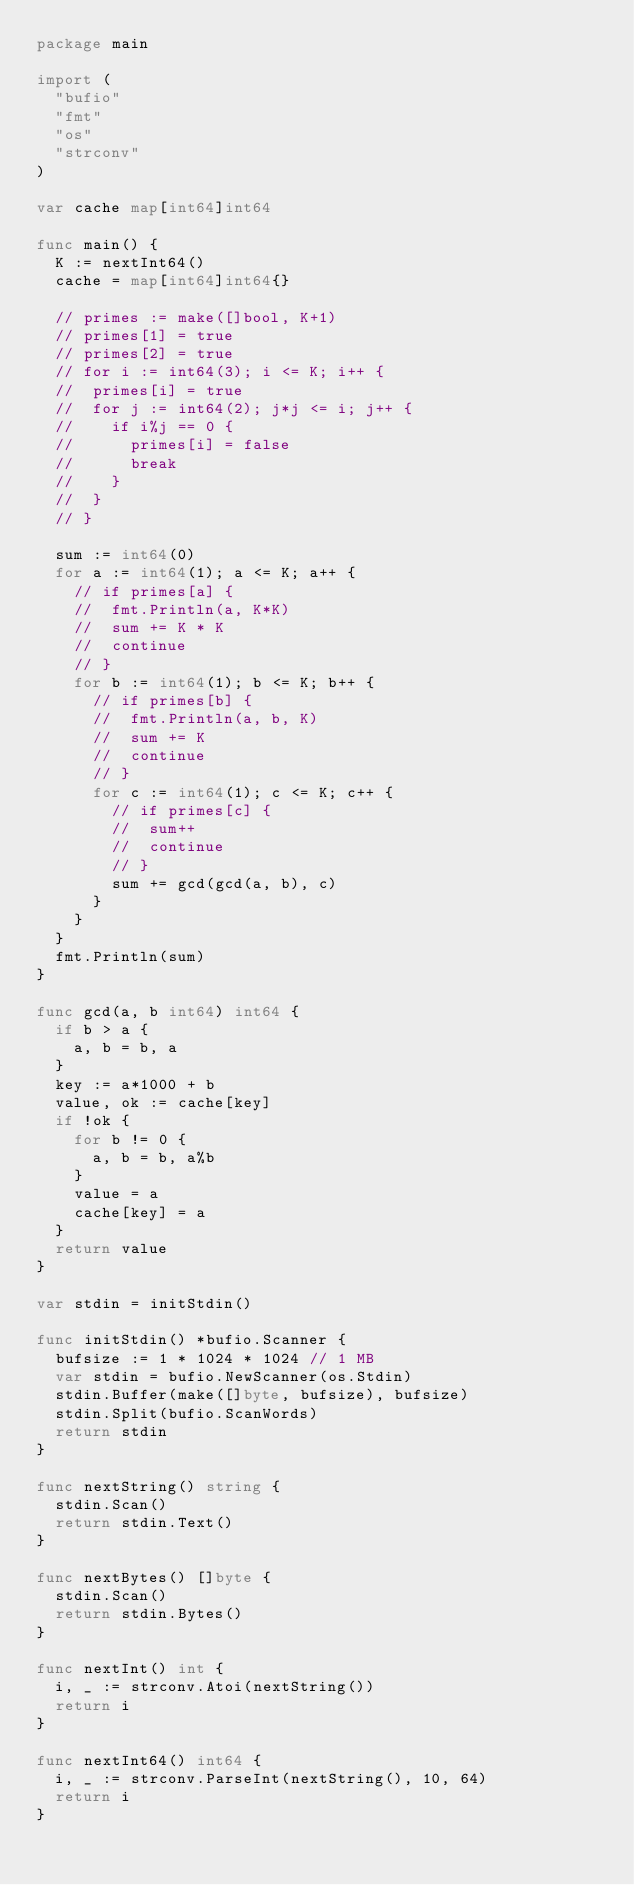Convert code to text. <code><loc_0><loc_0><loc_500><loc_500><_Go_>package main

import (
	"bufio"
	"fmt"
	"os"
	"strconv"
)

var cache map[int64]int64

func main() {
	K := nextInt64()
	cache = map[int64]int64{}

	// primes := make([]bool, K+1)
	// primes[1] = true
	// primes[2] = true
	// for i := int64(3); i <= K; i++ {
	// 	primes[i] = true
	// 	for j := int64(2); j*j <= i; j++ {
	// 		if i%j == 0 {
	// 			primes[i] = false
	// 			break
	// 		}
	// 	}
	// }

	sum := int64(0)
	for a := int64(1); a <= K; a++ {
		// if primes[a] {
		// 	fmt.Println(a, K*K)
		// 	sum += K * K
		// 	continue
		// }
		for b := int64(1); b <= K; b++ {
			// if primes[b] {
			// 	fmt.Println(a, b, K)
			// 	sum += K
			// 	continue
			// }
			for c := int64(1); c <= K; c++ {
				// if primes[c] {
				// 	sum++
				// 	continue
				// }
				sum += gcd(gcd(a, b), c)
			}
		}
	}
	fmt.Println(sum)
}

func gcd(a, b int64) int64 {
	if b > a {
		a, b = b, a
	}
	key := a*1000 + b
	value, ok := cache[key]
	if !ok {
		for b != 0 {
			a, b = b, a%b
		}
		value = a
		cache[key] = a
	}
	return value
}

var stdin = initStdin()

func initStdin() *bufio.Scanner {
	bufsize := 1 * 1024 * 1024 // 1 MB
	var stdin = bufio.NewScanner(os.Stdin)
	stdin.Buffer(make([]byte, bufsize), bufsize)
	stdin.Split(bufio.ScanWords)
	return stdin
}

func nextString() string {
	stdin.Scan()
	return stdin.Text()
}

func nextBytes() []byte {
	stdin.Scan()
	return stdin.Bytes()
}

func nextInt() int {
	i, _ := strconv.Atoi(nextString())
	return i
}

func nextInt64() int64 {
	i, _ := strconv.ParseInt(nextString(), 10, 64)
	return i
}
</code> 